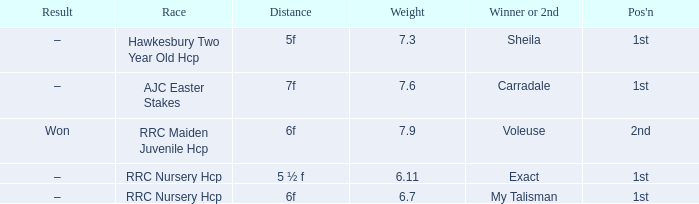What is the weight number when the distance was 5 ½ f? 1.0. 